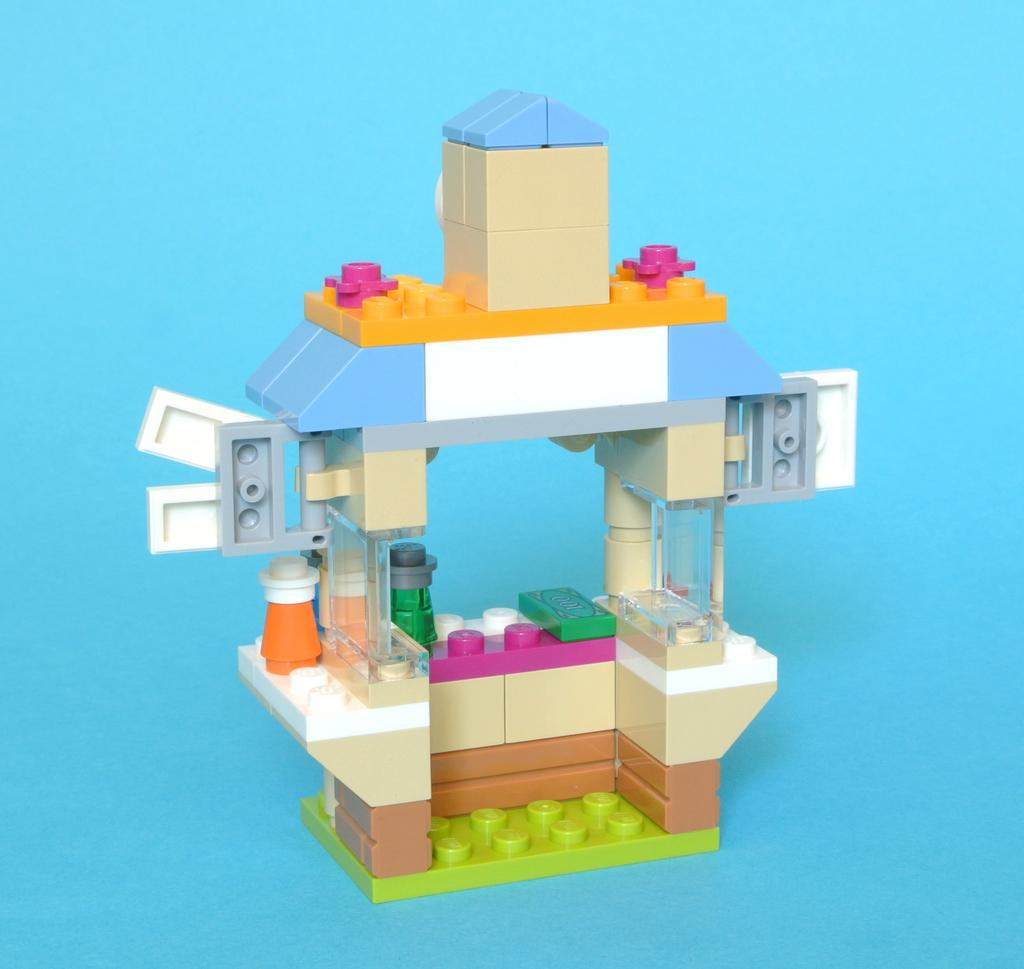What type of toy is in the image? There is a puzzle block toy in the image. What color is the background of the image? The background of the image is blue. How many cows are running in the image? There are no cows present in the image. 